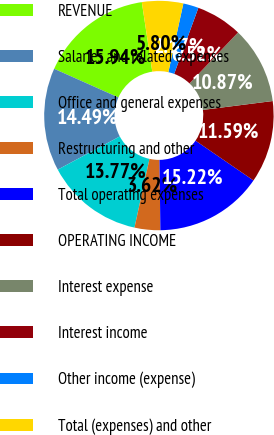Convert chart. <chart><loc_0><loc_0><loc_500><loc_500><pie_chart><fcel>REVENUE<fcel>Salaries and related expenses<fcel>Office and general expenses<fcel>Restructuring and other<fcel>Total operating expenses<fcel>OPERATING INCOME<fcel>Interest expense<fcel>Interest income<fcel>Other income (expense)<fcel>Total (expenses) and other<nl><fcel>15.94%<fcel>14.49%<fcel>13.77%<fcel>3.62%<fcel>15.22%<fcel>11.59%<fcel>10.87%<fcel>6.52%<fcel>2.17%<fcel>5.8%<nl></chart> 